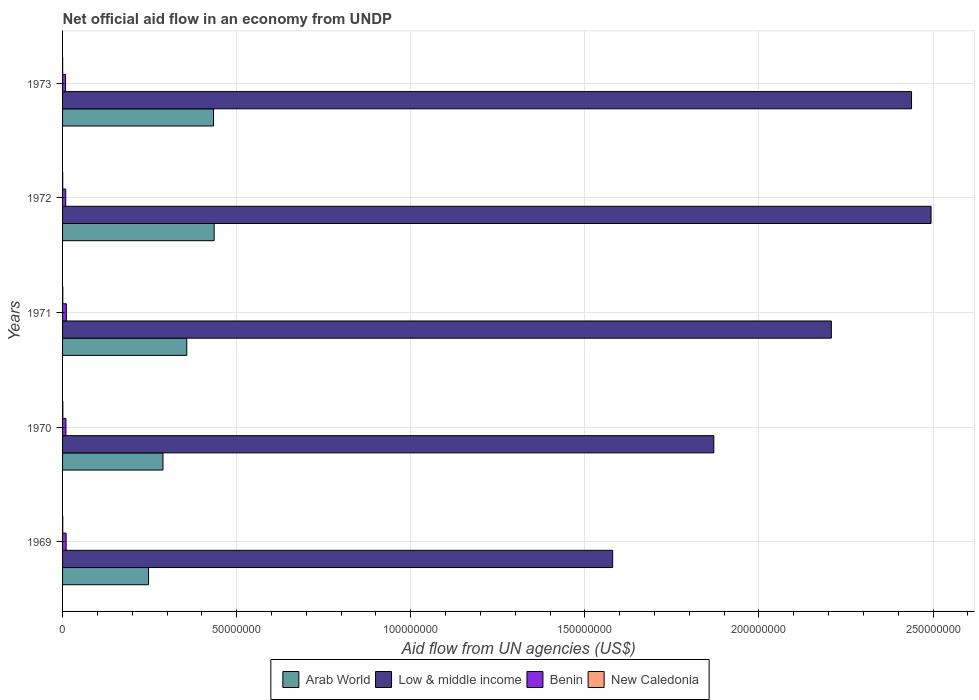How many groups of bars are there?
Make the answer very short. 5. Are the number of bars on each tick of the Y-axis equal?
Provide a short and direct response. Yes. How many bars are there on the 5th tick from the bottom?
Provide a succinct answer. 4. What is the label of the 4th group of bars from the top?
Offer a terse response. 1970. What is the net official aid flow in Arab World in 1970?
Keep it short and to the point. 2.88e+07. Across all years, what is the maximum net official aid flow in Benin?
Your answer should be compact. 1.09e+06. Across all years, what is the minimum net official aid flow in Arab World?
Your answer should be very brief. 2.47e+07. What is the total net official aid flow in Arab World in the graph?
Your answer should be compact. 1.76e+08. What is the difference between the net official aid flow in Arab World in 1971 and that in 1973?
Make the answer very short. -7.69e+06. What is the difference between the net official aid flow in Arab World in 1969 and the net official aid flow in Low & middle income in 1973?
Provide a succinct answer. -2.19e+08. What is the average net official aid flow in Low & middle income per year?
Ensure brevity in your answer.  2.12e+08. In the year 1973, what is the difference between the net official aid flow in Arab World and net official aid flow in Low & middle income?
Your response must be concise. -2.00e+08. In how many years, is the net official aid flow in New Caledonia greater than 140000000 US$?
Your answer should be compact. 0. What is the ratio of the net official aid flow in Arab World in 1969 to that in 1971?
Give a very brief answer. 0.69. Is the difference between the net official aid flow in Arab World in 1969 and 1972 greater than the difference between the net official aid flow in Low & middle income in 1969 and 1972?
Keep it short and to the point. Yes. What is the difference between the highest and the second highest net official aid flow in Low & middle income?
Ensure brevity in your answer.  5.61e+06. What is the difference between the highest and the lowest net official aid flow in Low & middle income?
Your answer should be compact. 9.14e+07. What does the 4th bar from the top in 1969 represents?
Keep it short and to the point. Arab World. What does the 1st bar from the bottom in 1971 represents?
Keep it short and to the point. Arab World. Is it the case that in every year, the sum of the net official aid flow in Arab World and net official aid flow in New Caledonia is greater than the net official aid flow in Benin?
Keep it short and to the point. Yes. How many bars are there?
Provide a succinct answer. 20. Are all the bars in the graph horizontal?
Give a very brief answer. Yes. How many years are there in the graph?
Offer a terse response. 5. Does the graph contain any zero values?
Offer a terse response. No. Where does the legend appear in the graph?
Offer a terse response. Bottom center. How many legend labels are there?
Your response must be concise. 4. What is the title of the graph?
Your response must be concise. Net official aid flow in an economy from UNDP. What is the label or title of the X-axis?
Ensure brevity in your answer.  Aid flow from UN agencies (US$). What is the Aid flow from UN agencies (US$) of Arab World in 1969?
Keep it short and to the point. 2.47e+07. What is the Aid flow from UN agencies (US$) in Low & middle income in 1969?
Keep it short and to the point. 1.58e+08. What is the Aid flow from UN agencies (US$) of Benin in 1969?
Offer a very short reply. 1.02e+06. What is the Aid flow from UN agencies (US$) of New Caledonia in 1969?
Your response must be concise. 5.00e+04. What is the Aid flow from UN agencies (US$) of Arab World in 1970?
Ensure brevity in your answer.  2.88e+07. What is the Aid flow from UN agencies (US$) in Low & middle income in 1970?
Your response must be concise. 1.87e+08. What is the Aid flow from UN agencies (US$) of Benin in 1970?
Provide a short and direct response. 9.70e+05. What is the Aid flow from UN agencies (US$) of Arab World in 1971?
Offer a terse response. 3.57e+07. What is the Aid flow from UN agencies (US$) in Low & middle income in 1971?
Your answer should be compact. 2.21e+08. What is the Aid flow from UN agencies (US$) of Benin in 1971?
Ensure brevity in your answer.  1.09e+06. What is the Aid flow from UN agencies (US$) of Arab World in 1972?
Your response must be concise. 4.35e+07. What is the Aid flow from UN agencies (US$) of Low & middle income in 1972?
Offer a terse response. 2.49e+08. What is the Aid flow from UN agencies (US$) of Benin in 1972?
Keep it short and to the point. 9.10e+05. What is the Aid flow from UN agencies (US$) of Arab World in 1973?
Your response must be concise. 4.34e+07. What is the Aid flow from UN agencies (US$) of Low & middle income in 1973?
Make the answer very short. 2.44e+08. What is the Aid flow from UN agencies (US$) in Benin in 1973?
Offer a very short reply. 8.50e+05. Across all years, what is the maximum Aid flow from UN agencies (US$) in Arab World?
Offer a very short reply. 4.35e+07. Across all years, what is the maximum Aid flow from UN agencies (US$) in Low & middle income?
Ensure brevity in your answer.  2.49e+08. Across all years, what is the maximum Aid flow from UN agencies (US$) in Benin?
Provide a succinct answer. 1.09e+06. Across all years, what is the minimum Aid flow from UN agencies (US$) in Arab World?
Your answer should be compact. 2.47e+07. Across all years, what is the minimum Aid flow from UN agencies (US$) of Low & middle income?
Provide a succinct answer. 1.58e+08. Across all years, what is the minimum Aid flow from UN agencies (US$) in Benin?
Your response must be concise. 8.50e+05. Across all years, what is the minimum Aid flow from UN agencies (US$) in New Caledonia?
Provide a succinct answer. 2.00e+04. What is the total Aid flow from UN agencies (US$) of Arab World in the graph?
Offer a terse response. 1.76e+08. What is the total Aid flow from UN agencies (US$) of Low & middle income in the graph?
Keep it short and to the point. 1.06e+09. What is the total Aid flow from UN agencies (US$) in Benin in the graph?
Give a very brief answer. 4.84e+06. What is the total Aid flow from UN agencies (US$) of New Caledonia in the graph?
Keep it short and to the point. 2.50e+05. What is the difference between the Aid flow from UN agencies (US$) in Arab World in 1969 and that in 1970?
Your answer should be very brief. -4.14e+06. What is the difference between the Aid flow from UN agencies (US$) of Low & middle income in 1969 and that in 1970?
Keep it short and to the point. -2.90e+07. What is the difference between the Aid flow from UN agencies (US$) in New Caledonia in 1969 and that in 1970?
Provide a succinct answer. -3.00e+04. What is the difference between the Aid flow from UN agencies (US$) in Arab World in 1969 and that in 1971?
Offer a terse response. -1.10e+07. What is the difference between the Aid flow from UN agencies (US$) of Low & middle income in 1969 and that in 1971?
Your answer should be very brief. -6.28e+07. What is the difference between the Aid flow from UN agencies (US$) of New Caledonia in 1969 and that in 1971?
Provide a succinct answer. -10000. What is the difference between the Aid flow from UN agencies (US$) of Arab World in 1969 and that in 1972?
Ensure brevity in your answer.  -1.88e+07. What is the difference between the Aid flow from UN agencies (US$) in Low & middle income in 1969 and that in 1972?
Ensure brevity in your answer.  -9.14e+07. What is the difference between the Aid flow from UN agencies (US$) in New Caledonia in 1969 and that in 1972?
Your answer should be compact. 10000. What is the difference between the Aid flow from UN agencies (US$) in Arab World in 1969 and that in 1973?
Your response must be concise. -1.87e+07. What is the difference between the Aid flow from UN agencies (US$) of Low & middle income in 1969 and that in 1973?
Offer a terse response. -8.58e+07. What is the difference between the Aid flow from UN agencies (US$) in Benin in 1969 and that in 1973?
Your answer should be very brief. 1.70e+05. What is the difference between the Aid flow from UN agencies (US$) of New Caledonia in 1969 and that in 1973?
Your answer should be compact. 3.00e+04. What is the difference between the Aid flow from UN agencies (US$) in Arab World in 1970 and that in 1971?
Give a very brief answer. -6.83e+06. What is the difference between the Aid flow from UN agencies (US$) of Low & middle income in 1970 and that in 1971?
Your answer should be compact. -3.38e+07. What is the difference between the Aid flow from UN agencies (US$) in Arab World in 1970 and that in 1972?
Make the answer very short. -1.47e+07. What is the difference between the Aid flow from UN agencies (US$) of Low & middle income in 1970 and that in 1972?
Your answer should be very brief. -6.24e+07. What is the difference between the Aid flow from UN agencies (US$) of Benin in 1970 and that in 1972?
Provide a short and direct response. 6.00e+04. What is the difference between the Aid flow from UN agencies (US$) of Arab World in 1970 and that in 1973?
Provide a short and direct response. -1.45e+07. What is the difference between the Aid flow from UN agencies (US$) in Low & middle income in 1970 and that in 1973?
Provide a short and direct response. -5.68e+07. What is the difference between the Aid flow from UN agencies (US$) of Benin in 1970 and that in 1973?
Your response must be concise. 1.20e+05. What is the difference between the Aid flow from UN agencies (US$) of Arab World in 1971 and that in 1972?
Ensure brevity in your answer.  -7.86e+06. What is the difference between the Aid flow from UN agencies (US$) in Low & middle income in 1971 and that in 1972?
Keep it short and to the point. -2.86e+07. What is the difference between the Aid flow from UN agencies (US$) of Arab World in 1971 and that in 1973?
Your response must be concise. -7.69e+06. What is the difference between the Aid flow from UN agencies (US$) in Low & middle income in 1971 and that in 1973?
Your response must be concise. -2.30e+07. What is the difference between the Aid flow from UN agencies (US$) of Low & middle income in 1972 and that in 1973?
Ensure brevity in your answer.  5.61e+06. What is the difference between the Aid flow from UN agencies (US$) of Benin in 1972 and that in 1973?
Make the answer very short. 6.00e+04. What is the difference between the Aid flow from UN agencies (US$) of Arab World in 1969 and the Aid flow from UN agencies (US$) of Low & middle income in 1970?
Offer a terse response. -1.62e+08. What is the difference between the Aid flow from UN agencies (US$) of Arab World in 1969 and the Aid flow from UN agencies (US$) of Benin in 1970?
Give a very brief answer. 2.37e+07. What is the difference between the Aid flow from UN agencies (US$) of Arab World in 1969 and the Aid flow from UN agencies (US$) of New Caledonia in 1970?
Keep it short and to the point. 2.46e+07. What is the difference between the Aid flow from UN agencies (US$) of Low & middle income in 1969 and the Aid flow from UN agencies (US$) of Benin in 1970?
Provide a short and direct response. 1.57e+08. What is the difference between the Aid flow from UN agencies (US$) of Low & middle income in 1969 and the Aid flow from UN agencies (US$) of New Caledonia in 1970?
Ensure brevity in your answer.  1.58e+08. What is the difference between the Aid flow from UN agencies (US$) of Benin in 1969 and the Aid flow from UN agencies (US$) of New Caledonia in 1970?
Provide a succinct answer. 9.40e+05. What is the difference between the Aid flow from UN agencies (US$) of Arab World in 1969 and the Aid flow from UN agencies (US$) of Low & middle income in 1971?
Offer a very short reply. -1.96e+08. What is the difference between the Aid flow from UN agencies (US$) in Arab World in 1969 and the Aid flow from UN agencies (US$) in Benin in 1971?
Provide a short and direct response. 2.36e+07. What is the difference between the Aid flow from UN agencies (US$) in Arab World in 1969 and the Aid flow from UN agencies (US$) in New Caledonia in 1971?
Provide a short and direct response. 2.46e+07. What is the difference between the Aid flow from UN agencies (US$) in Low & middle income in 1969 and the Aid flow from UN agencies (US$) in Benin in 1971?
Offer a very short reply. 1.57e+08. What is the difference between the Aid flow from UN agencies (US$) of Low & middle income in 1969 and the Aid flow from UN agencies (US$) of New Caledonia in 1971?
Your answer should be very brief. 1.58e+08. What is the difference between the Aid flow from UN agencies (US$) in Benin in 1969 and the Aid flow from UN agencies (US$) in New Caledonia in 1971?
Make the answer very short. 9.60e+05. What is the difference between the Aid flow from UN agencies (US$) in Arab World in 1969 and the Aid flow from UN agencies (US$) in Low & middle income in 1972?
Ensure brevity in your answer.  -2.25e+08. What is the difference between the Aid flow from UN agencies (US$) of Arab World in 1969 and the Aid flow from UN agencies (US$) of Benin in 1972?
Your answer should be very brief. 2.38e+07. What is the difference between the Aid flow from UN agencies (US$) in Arab World in 1969 and the Aid flow from UN agencies (US$) in New Caledonia in 1972?
Make the answer very short. 2.47e+07. What is the difference between the Aid flow from UN agencies (US$) in Low & middle income in 1969 and the Aid flow from UN agencies (US$) in Benin in 1972?
Provide a short and direct response. 1.57e+08. What is the difference between the Aid flow from UN agencies (US$) in Low & middle income in 1969 and the Aid flow from UN agencies (US$) in New Caledonia in 1972?
Provide a short and direct response. 1.58e+08. What is the difference between the Aid flow from UN agencies (US$) in Benin in 1969 and the Aid flow from UN agencies (US$) in New Caledonia in 1972?
Your answer should be very brief. 9.80e+05. What is the difference between the Aid flow from UN agencies (US$) in Arab World in 1969 and the Aid flow from UN agencies (US$) in Low & middle income in 1973?
Give a very brief answer. -2.19e+08. What is the difference between the Aid flow from UN agencies (US$) in Arab World in 1969 and the Aid flow from UN agencies (US$) in Benin in 1973?
Your response must be concise. 2.38e+07. What is the difference between the Aid flow from UN agencies (US$) in Arab World in 1969 and the Aid flow from UN agencies (US$) in New Caledonia in 1973?
Provide a short and direct response. 2.47e+07. What is the difference between the Aid flow from UN agencies (US$) of Low & middle income in 1969 and the Aid flow from UN agencies (US$) of Benin in 1973?
Give a very brief answer. 1.57e+08. What is the difference between the Aid flow from UN agencies (US$) of Low & middle income in 1969 and the Aid flow from UN agencies (US$) of New Caledonia in 1973?
Provide a short and direct response. 1.58e+08. What is the difference between the Aid flow from UN agencies (US$) of Arab World in 1970 and the Aid flow from UN agencies (US$) of Low & middle income in 1971?
Offer a terse response. -1.92e+08. What is the difference between the Aid flow from UN agencies (US$) of Arab World in 1970 and the Aid flow from UN agencies (US$) of Benin in 1971?
Keep it short and to the point. 2.78e+07. What is the difference between the Aid flow from UN agencies (US$) of Arab World in 1970 and the Aid flow from UN agencies (US$) of New Caledonia in 1971?
Provide a succinct answer. 2.88e+07. What is the difference between the Aid flow from UN agencies (US$) in Low & middle income in 1970 and the Aid flow from UN agencies (US$) in Benin in 1971?
Give a very brief answer. 1.86e+08. What is the difference between the Aid flow from UN agencies (US$) of Low & middle income in 1970 and the Aid flow from UN agencies (US$) of New Caledonia in 1971?
Give a very brief answer. 1.87e+08. What is the difference between the Aid flow from UN agencies (US$) of Benin in 1970 and the Aid flow from UN agencies (US$) of New Caledonia in 1971?
Provide a short and direct response. 9.10e+05. What is the difference between the Aid flow from UN agencies (US$) in Arab World in 1970 and the Aid flow from UN agencies (US$) in Low & middle income in 1972?
Offer a very short reply. -2.21e+08. What is the difference between the Aid flow from UN agencies (US$) of Arab World in 1970 and the Aid flow from UN agencies (US$) of Benin in 1972?
Your answer should be compact. 2.79e+07. What is the difference between the Aid flow from UN agencies (US$) in Arab World in 1970 and the Aid flow from UN agencies (US$) in New Caledonia in 1972?
Your response must be concise. 2.88e+07. What is the difference between the Aid flow from UN agencies (US$) of Low & middle income in 1970 and the Aid flow from UN agencies (US$) of Benin in 1972?
Keep it short and to the point. 1.86e+08. What is the difference between the Aid flow from UN agencies (US$) in Low & middle income in 1970 and the Aid flow from UN agencies (US$) in New Caledonia in 1972?
Your answer should be compact. 1.87e+08. What is the difference between the Aid flow from UN agencies (US$) in Benin in 1970 and the Aid flow from UN agencies (US$) in New Caledonia in 1972?
Make the answer very short. 9.30e+05. What is the difference between the Aid flow from UN agencies (US$) of Arab World in 1970 and the Aid flow from UN agencies (US$) of Low & middle income in 1973?
Your answer should be very brief. -2.15e+08. What is the difference between the Aid flow from UN agencies (US$) of Arab World in 1970 and the Aid flow from UN agencies (US$) of Benin in 1973?
Offer a very short reply. 2.80e+07. What is the difference between the Aid flow from UN agencies (US$) of Arab World in 1970 and the Aid flow from UN agencies (US$) of New Caledonia in 1973?
Your answer should be very brief. 2.88e+07. What is the difference between the Aid flow from UN agencies (US$) of Low & middle income in 1970 and the Aid flow from UN agencies (US$) of Benin in 1973?
Make the answer very short. 1.86e+08. What is the difference between the Aid flow from UN agencies (US$) in Low & middle income in 1970 and the Aid flow from UN agencies (US$) in New Caledonia in 1973?
Your response must be concise. 1.87e+08. What is the difference between the Aid flow from UN agencies (US$) of Benin in 1970 and the Aid flow from UN agencies (US$) of New Caledonia in 1973?
Your answer should be very brief. 9.50e+05. What is the difference between the Aid flow from UN agencies (US$) of Arab World in 1971 and the Aid flow from UN agencies (US$) of Low & middle income in 1972?
Ensure brevity in your answer.  -2.14e+08. What is the difference between the Aid flow from UN agencies (US$) in Arab World in 1971 and the Aid flow from UN agencies (US$) in Benin in 1972?
Your answer should be compact. 3.48e+07. What is the difference between the Aid flow from UN agencies (US$) in Arab World in 1971 and the Aid flow from UN agencies (US$) in New Caledonia in 1972?
Offer a terse response. 3.56e+07. What is the difference between the Aid flow from UN agencies (US$) in Low & middle income in 1971 and the Aid flow from UN agencies (US$) in Benin in 1972?
Keep it short and to the point. 2.20e+08. What is the difference between the Aid flow from UN agencies (US$) of Low & middle income in 1971 and the Aid flow from UN agencies (US$) of New Caledonia in 1972?
Provide a short and direct response. 2.21e+08. What is the difference between the Aid flow from UN agencies (US$) in Benin in 1971 and the Aid flow from UN agencies (US$) in New Caledonia in 1972?
Your answer should be very brief. 1.05e+06. What is the difference between the Aid flow from UN agencies (US$) of Arab World in 1971 and the Aid flow from UN agencies (US$) of Low & middle income in 1973?
Your response must be concise. -2.08e+08. What is the difference between the Aid flow from UN agencies (US$) of Arab World in 1971 and the Aid flow from UN agencies (US$) of Benin in 1973?
Offer a very short reply. 3.48e+07. What is the difference between the Aid flow from UN agencies (US$) in Arab World in 1971 and the Aid flow from UN agencies (US$) in New Caledonia in 1973?
Offer a terse response. 3.56e+07. What is the difference between the Aid flow from UN agencies (US$) of Low & middle income in 1971 and the Aid flow from UN agencies (US$) of Benin in 1973?
Your answer should be compact. 2.20e+08. What is the difference between the Aid flow from UN agencies (US$) in Low & middle income in 1971 and the Aid flow from UN agencies (US$) in New Caledonia in 1973?
Keep it short and to the point. 2.21e+08. What is the difference between the Aid flow from UN agencies (US$) of Benin in 1971 and the Aid flow from UN agencies (US$) of New Caledonia in 1973?
Give a very brief answer. 1.07e+06. What is the difference between the Aid flow from UN agencies (US$) in Arab World in 1972 and the Aid flow from UN agencies (US$) in Low & middle income in 1973?
Give a very brief answer. -2.00e+08. What is the difference between the Aid flow from UN agencies (US$) of Arab World in 1972 and the Aid flow from UN agencies (US$) of Benin in 1973?
Ensure brevity in your answer.  4.27e+07. What is the difference between the Aid flow from UN agencies (US$) of Arab World in 1972 and the Aid flow from UN agencies (US$) of New Caledonia in 1973?
Ensure brevity in your answer.  4.35e+07. What is the difference between the Aid flow from UN agencies (US$) in Low & middle income in 1972 and the Aid flow from UN agencies (US$) in Benin in 1973?
Provide a succinct answer. 2.49e+08. What is the difference between the Aid flow from UN agencies (US$) in Low & middle income in 1972 and the Aid flow from UN agencies (US$) in New Caledonia in 1973?
Your answer should be very brief. 2.49e+08. What is the difference between the Aid flow from UN agencies (US$) of Benin in 1972 and the Aid flow from UN agencies (US$) of New Caledonia in 1973?
Make the answer very short. 8.90e+05. What is the average Aid flow from UN agencies (US$) in Arab World per year?
Your answer should be very brief. 3.52e+07. What is the average Aid flow from UN agencies (US$) in Low & middle income per year?
Give a very brief answer. 2.12e+08. What is the average Aid flow from UN agencies (US$) of Benin per year?
Make the answer very short. 9.68e+05. What is the average Aid flow from UN agencies (US$) of New Caledonia per year?
Keep it short and to the point. 5.00e+04. In the year 1969, what is the difference between the Aid flow from UN agencies (US$) in Arab World and Aid flow from UN agencies (US$) in Low & middle income?
Provide a succinct answer. -1.33e+08. In the year 1969, what is the difference between the Aid flow from UN agencies (US$) in Arab World and Aid flow from UN agencies (US$) in Benin?
Make the answer very short. 2.37e+07. In the year 1969, what is the difference between the Aid flow from UN agencies (US$) in Arab World and Aid flow from UN agencies (US$) in New Caledonia?
Ensure brevity in your answer.  2.46e+07. In the year 1969, what is the difference between the Aid flow from UN agencies (US$) in Low & middle income and Aid flow from UN agencies (US$) in Benin?
Make the answer very short. 1.57e+08. In the year 1969, what is the difference between the Aid flow from UN agencies (US$) in Low & middle income and Aid flow from UN agencies (US$) in New Caledonia?
Ensure brevity in your answer.  1.58e+08. In the year 1969, what is the difference between the Aid flow from UN agencies (US$) in Benin and Aid flow from UN agencies (US$) in New Caledonia?
Your answer should be compact. 9.70e+05. In the year 1970, what is the difference between the Aid flow from UN agencies (US$) of Arab World and Aid flow from UN agencies (US$) of Low & middle income?
Your answer should be compact. -1.58e+08. In the year 1970, what is the difference between the Aid flow from UN agencies (US$) of Arab World and Aid flow from UN agencies (US$) of Benin?
Offer a very short reply. 2.79e+07. In the year 1970, what is the difference between the Aid flow from UN agencies (US$) of Arab World and Aid flow from UN agencies (US$) of New Caledonia?
Your answer should be very brief. 2.88e+07. In the year 1970, what is the difference between the Aid flow from UN agencies (US$) of Low & middle income and Aid flow from UN agencies (US$) of Benin?
Your answer should be very brief. 1.86e+08. In the year 1970, what is the difference between the Aid flow from UN agencies (US$) in Low & middle income and Aid flow from UN agencies (US$) in New Caledonia?
Keep it short and to the point. 1.87e+08. In the year 1970, what is the difference between the Aid flow from UN agencies (US$) of Benin and Aid flow from UN agencies (US$) of New Caledonia?
Ensure brevity in your answer.  8.90e+05. In the year 1971, what is the difference between the Aid flow from UN agencies (US$) of Arab World and Aid flow from UN agencies (US$) of Low & middle income?
Offer a very short reply. -1.85e+08. In the year 1971, what is the difference between the Aid flow from UN agencies (US$) of Arab World and Aid flow from UN agencies (US$) of Benin?
Give a very brief answer. 3.46e+07. In the year 1971, what is the difference between the Aid flow from UN agencies (US$) of Arab World and Aid flow from UN agencies (US$) of New Caledonia?
Your answer should be compact. 3.56e+07. In the year 1971, what is the difference between the Aid flow from UN agencies (US$) of Low & middle income and Aid flow from UN agencies (US$) of Benin?
Your answer should be very brief. 2.20e+08. In the year 1971, what is the difference between the Aid flow from UN agencies (US$) in Low & middle income and Aid flow from UN agencies (US$) in New Caledonia?
Your response must be concise. 2.21e+08. In the year 1971, what is the difference between the Aid flow from UN agencies (US$) in Benin and Aid flow from UN agencies (US$) in New Caledonia?
Provide a succinct answer. 1.03e+06. In the year 1972, what is the difference between the Aid flow from UN agencies (US$) in Arab World and Aid flow from UN agencies (US$) in Low & middle income?
Your response must be concise. -2.06e+08. In the year 1972, what is the difference between the Aid flow from UN agencies (US$) of Arab World and Aid flow from UN agencies (US$) of Benin?
Make the answer very short. 4.26e+07. In the year 1972, what is the difference between the Aid flow from UN agencies (US$) of Arab World and Aid flow from UN agencies (US$) of New Caledonia?
Your answer should be compact. 4.35e+07. In the year 1972, what is the difference between the Aid flow from UN agencies (US$) of Low & middle income and Aid flow from UN agencies (US$) of Benin?
Keep it short and to the point. 2.49e+08. In the year 1972, what is the difference between the Aid flow from UN agencies (US$) in Low & middle income and Aid flow from UN agencies (US$) in New Caledonia?
Offer a very short reply. 2.49e+08. In the year 1972, what is the difference between the Aid flow from UN agencies (US$) of Benin and Aid flow from UN agencies (US$) of New Caledonia?
Make the answer very short. 8.70e+05. In the year 1973, what is the difference between the Aid flow from UN agencies (US$) of Arab World and Aid flow from UN agencies (US$) of Low & middle income?
Provide a succinct answer. -2.00e+08. In the year 1973, what is the difference between the Aid flow from UN agencies (US$) in Arab World and Aid flow from UN agencies (US$) in Benin?
Your response must be concise. 4.25e+07. In the year 1973, what is the difference between the Aid flow from UN agencies (US$) in Arab World and Aid flow from UN agencies (US$) in New Caledonia?
Give a very brief answer. 4.33e+07. In the year 1973, what is the difference between the Aid flow from UN agencies (US$) of Low & middle income and Aid flow from UN agencies (US$) of Benin?
Provide a succinct answer. 2.43e+08. In the year 1973, what is the difference between the Aid flow from UN agencies (US$) in Low & middle income and Aid flow from UN agencies (US$) in New Caledonia?
Provide a short and direct response. 2.44e+08. In the year 1973, what is the difference between the Aid flow from UN agencies (US$) of Benin and Aid flow from UN agencies (US$) of New Caledonia?
Provide a succinct answer. 8.30e+05. What is the ratio of the Aid flow from UN agencies (US$) in Arab World in 1969 to that in 1970?
Provide a succinct answer. 0.86. What is the ratio of the Aid flow from UN agencies (US$) in Low & middle income in 1969 to that in 1970?
Your answer should be very brief. 0.84. What is the ratio of the Aid flow from UN agencies (US$) in Benin in 1969 to that in 1970?
Your answer should be compact. 1.05. What is the ratio of the Aid flow from UN agencies (US$) of Arab World in 1969 to that in 1971?
Your answer should be compact. 0.69. What is the ratio of the Aid flow from UN agencies (US$) of Low & middle income in 1969 to that in 1971?
Offer a very short reply. 0.72. What is the ratio of the Aid flow from UN agencies (US$) of Benin in 1969 to that in 1971?
Make the answer very short. 0.94. What is the ratio of the Aid flow from UN agencies (US$) in Arab World in 1969 to that in 1972?
Make the answer very short. 0.57. What is the ratio of the Aid flow from UN agencies (US$) in Low & middle income in 1969 to that in 1972?
Offer a very short reply. 0.63. What is the ratio of the Aid flow from UN agencies (US$) in Benin in 1969 to that in 1972?
Your answer should be very brief. 1.12. What is the ratio of the Aid flow from UN agencies (US$) of Arab World in 1969 to that in 1973?
Provide a succinct answer. 0.57. What is the ratio of the Aid flow from UN agencies (US$) of Low & middle income in 1969 to that in 1973?
Offer a very short reply. 0.65. What is the ratio of the Aid flow from UN agencies (US$) of New Caledonia in 1969 to that in 1973?
Offer a very short reply. 2.5. What is the ratio of the Aid flow from UN agencies (US$) of Arab World in 1970 to that in 1971?
Make the answer very short. 0.81. What is the ratio of the Aid flow from UN agencies (US$) in Low & middle income in 1970 to that in 1971?
Provide a succinct answer. 0.85. What is the ratio of the Aid flow from UN agencies (US$) in Benin in 1970 to that in 1971?
Offer a terse response. 0.89. What is the ratio of the Aid flow from UN agencies (US$) of Arab World in 1970 to that in 1972?
Offer a very short reply. 0.66. What is the ratio of the Aid flow from UN agencies (US$) in Low & middle income in 1970 to that in 1972?
Make the answer very short. 0.75. What is the ratio of the Aid flow from UN agencies (US$) in Benin in 1970 to that in 1972?
Ensure brevity in your answer.  1.07. What is the ratio of the Aid flow from UN agencies (US$) of New Caledonia in 1970 to that in 1972?
Offer a very short reply. 2. What is the ratio of the Aid flow from UN agencies (US$) in Arab World in 1970 to that in 1973?
Provide a succinct answer. 0.67. What is the ratio of the Aid flow from UN agencies (US$) of Low & middle income in 1970 to that in 1973?
Provide a short and direct response. 0.77. What is the ratio of the Aid flow from UN agencies (US$) of Benin in 1970 to that in 1973?
Offer a very short reply. 1.14. What is the ratio of the Aid flow from UN agencies (US$) of Arab World in 1971 to that in 1972?
Provide a succinct answer. 0.82. What is the ratio of the Aid flow from UN agencies (US$) of Low & middle income in 1971 to that in 1972?
Offer a very short reply. 0.89. What is the ratio of the Aid flow from UN agencies (US$) of Benin in 1971 to that in 1972?
Make the answer very short. 1.2. What is the ratio of the Aid flow from UN agencies (US$) in Arab World in 1971 to that in 1973?
Your response must be concise. 0.82. What is the ratio of the Aid flow from UN agencies (US$) of Low & middle income in 1971 to that in 1973?
Your answer should be very brief. 0.91. What is the ratio of the Aid flow from UN agencies (US$) in Benin in 1971 to that in 1973?
Your answer should be very brief. 1.28. What is the ratio of the Aid flow from UN agencies (US$) of New Caledonia in 1971 to that in 1973?
Ensure brevity in your answer.  3. What is the ratio of the Aid flow from UN agencies (US$) of Benin in 1972 to that in 1973?
Provide a succinct answer. 1.07. What is the ratio of the Aid flow from UN agencies (US$) of New Caledonia in 1972 to that in 1973?
Give a very brief answer. 2. What is the difference between the highest and the second highest Aid flow from UN agencies (US$) of Arab World?
Ensure brevity in your answer.  1.70e+05. What is the difference between the highest and the second highest Aid flow from UN agencies (US$) in Low & middle income?
Make the answer very short. 5.61e+06. What is the difference between the highest and the second highest Aid flow from UN agencies (US$) in Benin?
Offer a very short reply. 7.00e+04. What is the difference between the highest and the lowest Aid flow from UN agencies (US$) in Arab World?
Provide a succinct answer. 1.88e+07. What is the difference between the highest and the lowest Aid flow from UN agencies (US$) of Low & middle income?
Your answer should be very brief. 9.14e+07. 